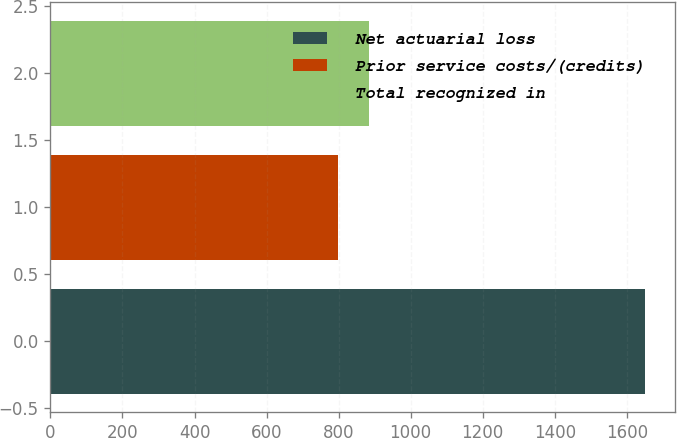<chart> <loc_0><loc_0><loc_500><loc_500><bar_chart><fcel>Net actuarial loss<fcel>Prior service costs/(credits)<fcel>Total recognized in<nl><fcel>1651<fcel>799<fcel>884.2<nl></chart> 